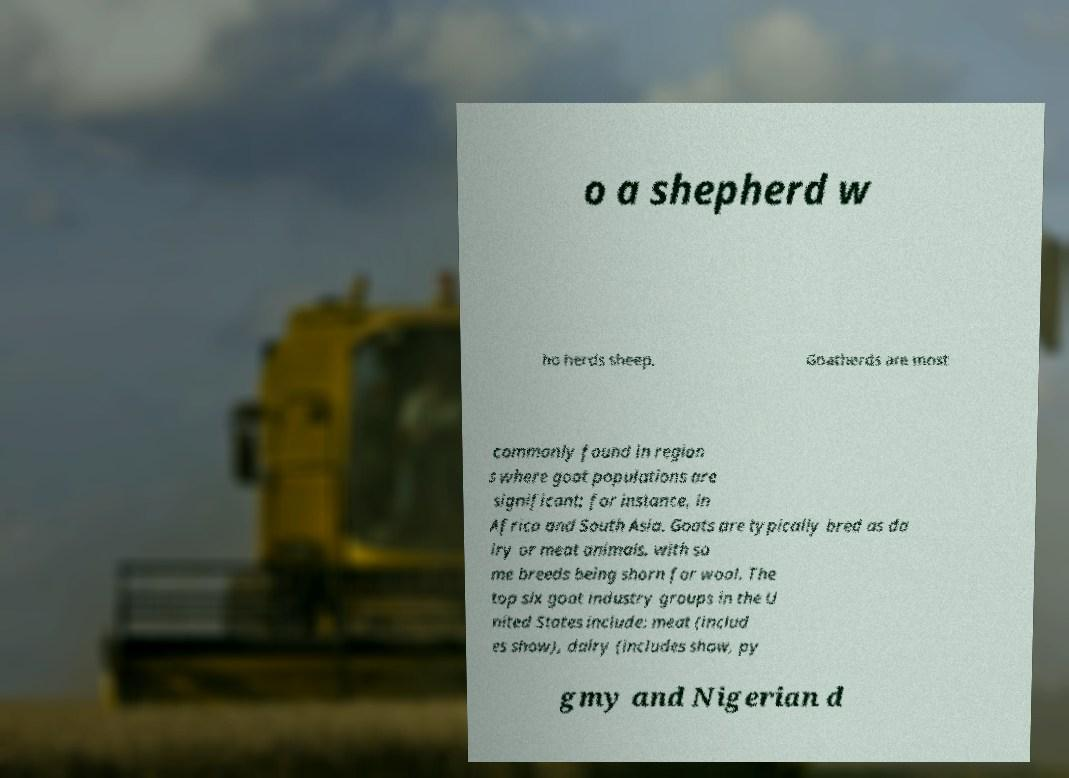There's text embedded in this image that I need extracted. Can you transcribe it verbatim? o a shepherd w ho herds sheep. Goatherds are most commonly found in region s where goat populations are significant; for instance, in Africa and South Asia. Goats are typically bred as da iry or meat animals, with so me breeds being shorn for wool. The top six goat industry groups in the U nited States include: meat (includ es show), dairy (includes show, py gmy and Nigerian d 